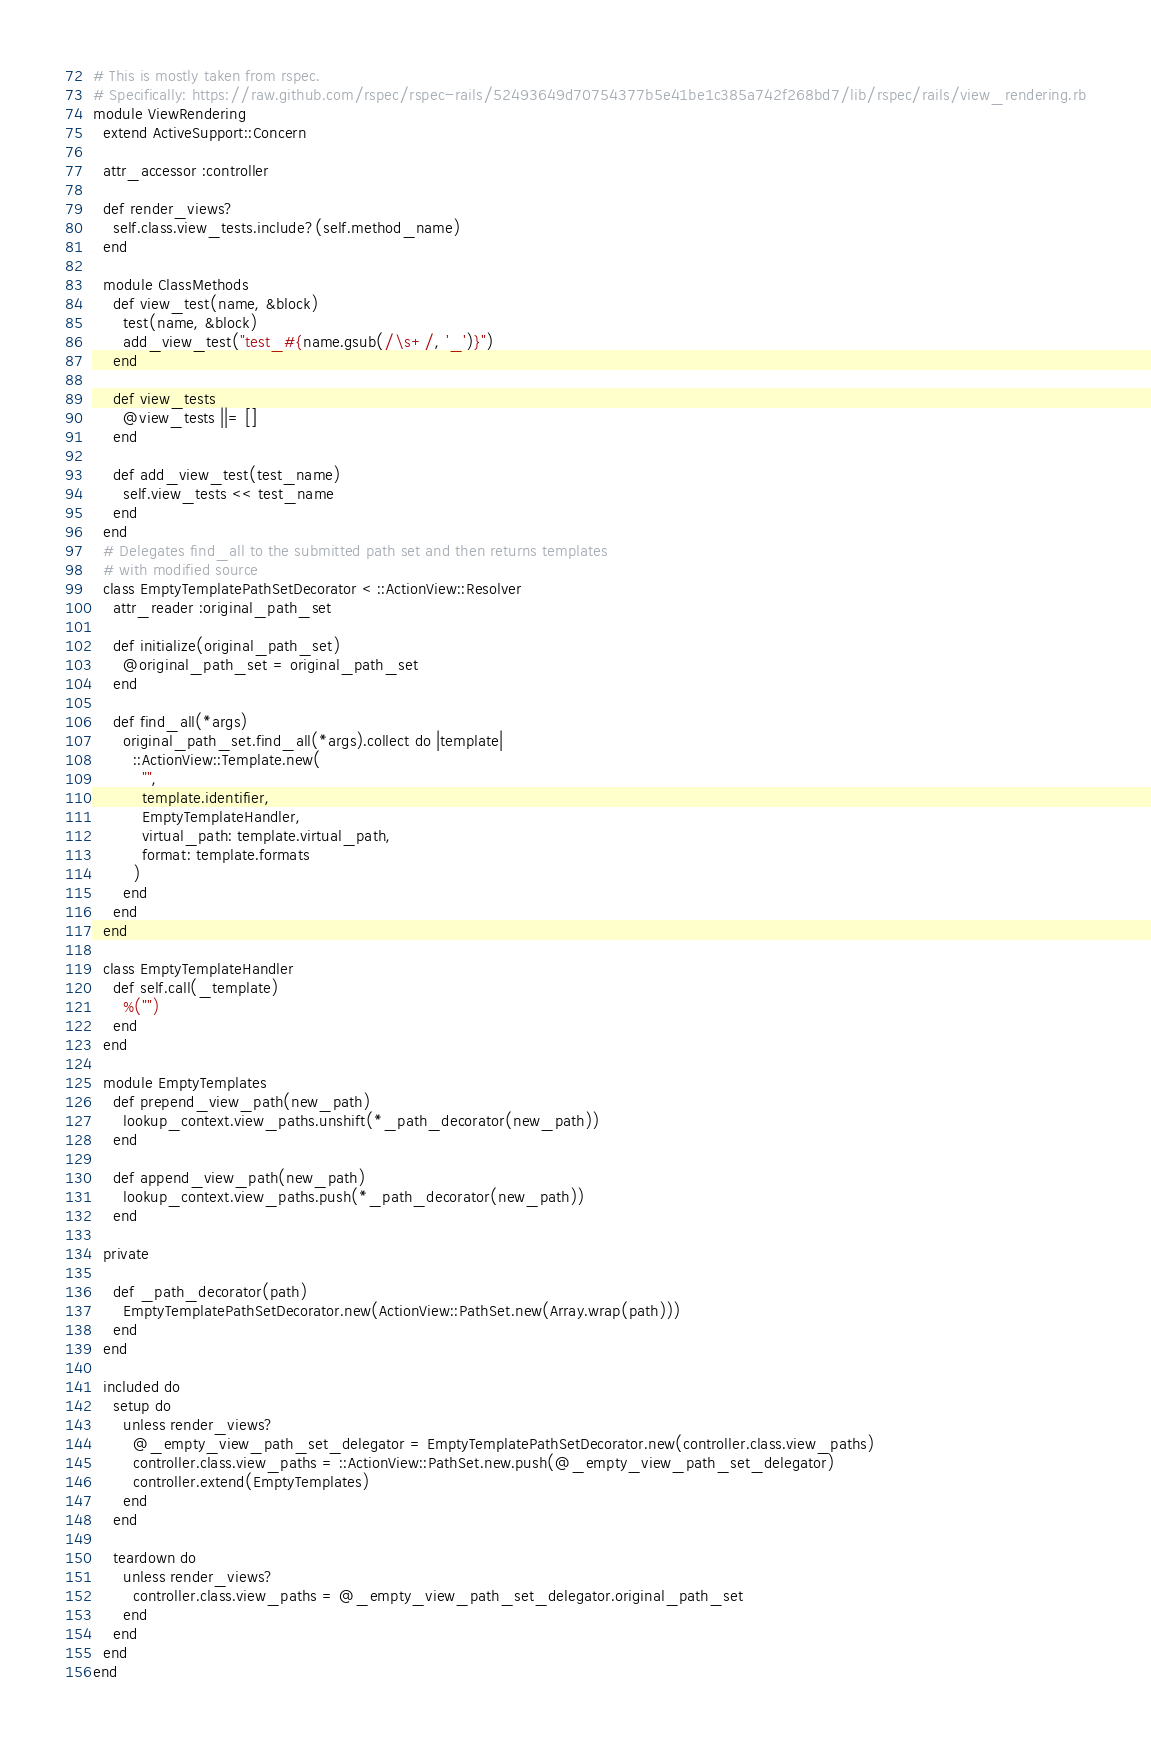Convert code to text. <code><loc_0><loc_0><loc_500><loc_500><_Ruby_># This is mostly taken from rspec.
# Specifically: https://raw.github.com/rspec/rspec-rails/52493649d70754377b5e41be1c385a742f268bd7/lib/rspec/rails/view_rendering.rb
module ViewRendering
  extend ActiveSupport::Concern

  attr_accessor :controller

  def render_views?
    self.class.view_tests.include?(self.method_name)
  end

  module ClassMethods
    def view_test(name, &block)
      test(name, &block)
      add_view_test("test_#{name.gsub(/\s+/, '_')}")
    end

    def view_tests
      @view_tests ||= []
    end

    def add_view_test(test_name)
      self.view_tests << test_name
    end
  end
  # Delegates find_all to the submitted path set and then returns templates
  # with modified source
  class EmptyTemplatePathSetDecorator < ::ActionView::Resolver
    attr_reader :original_path_set

    def initialize(original_path_set)
      @original_path_set = original_path_set
    end

    def find_all(*args)
      original_path_set.find_all(*args).collect do |template|
        ::ActionView::Template.new(
          "",
          template.identifier,
          EmptyTemplateHandler,
          virtual_path: template.virtual_path,
          format: template.formats
        )
      end
    end
  end

  class EmptyTemplateHandler
    def self.call(_template)
      %("")
    end
  end

  module EmptyTemplates
    def prepend_view_path(new_path)
      lookup_context.view_paths.unshift(*_path_decorator(new_path))
    end

    def append_view_path(new_path)
      lookup_context.view_paths.push(*_path_decorator(new_path))
    end

  private

    def _path_decorator(path)
      EmptyTemplatePathSetDecorator.new(ActionView::PathSet.new(Array.wrap(path)))
    end
  end

  included do
    setup do
      unless render_views?
        @_empty_view_path_set_delegator = EmptyTemplatePathSetDecorator.new(controller.class.view_paths)
        controller.class.view_paths = ::ActionView::PathSet.new.push(@_empty_view_path_set_delegator)
        controller.extend(EmptyTemplates)
      end
    end

    teardown do
      unless render_views?
        controller.class.view_paths = @_empty_view_path_set_delegator.original_path_set
      end
    end
  end
end
</code> 